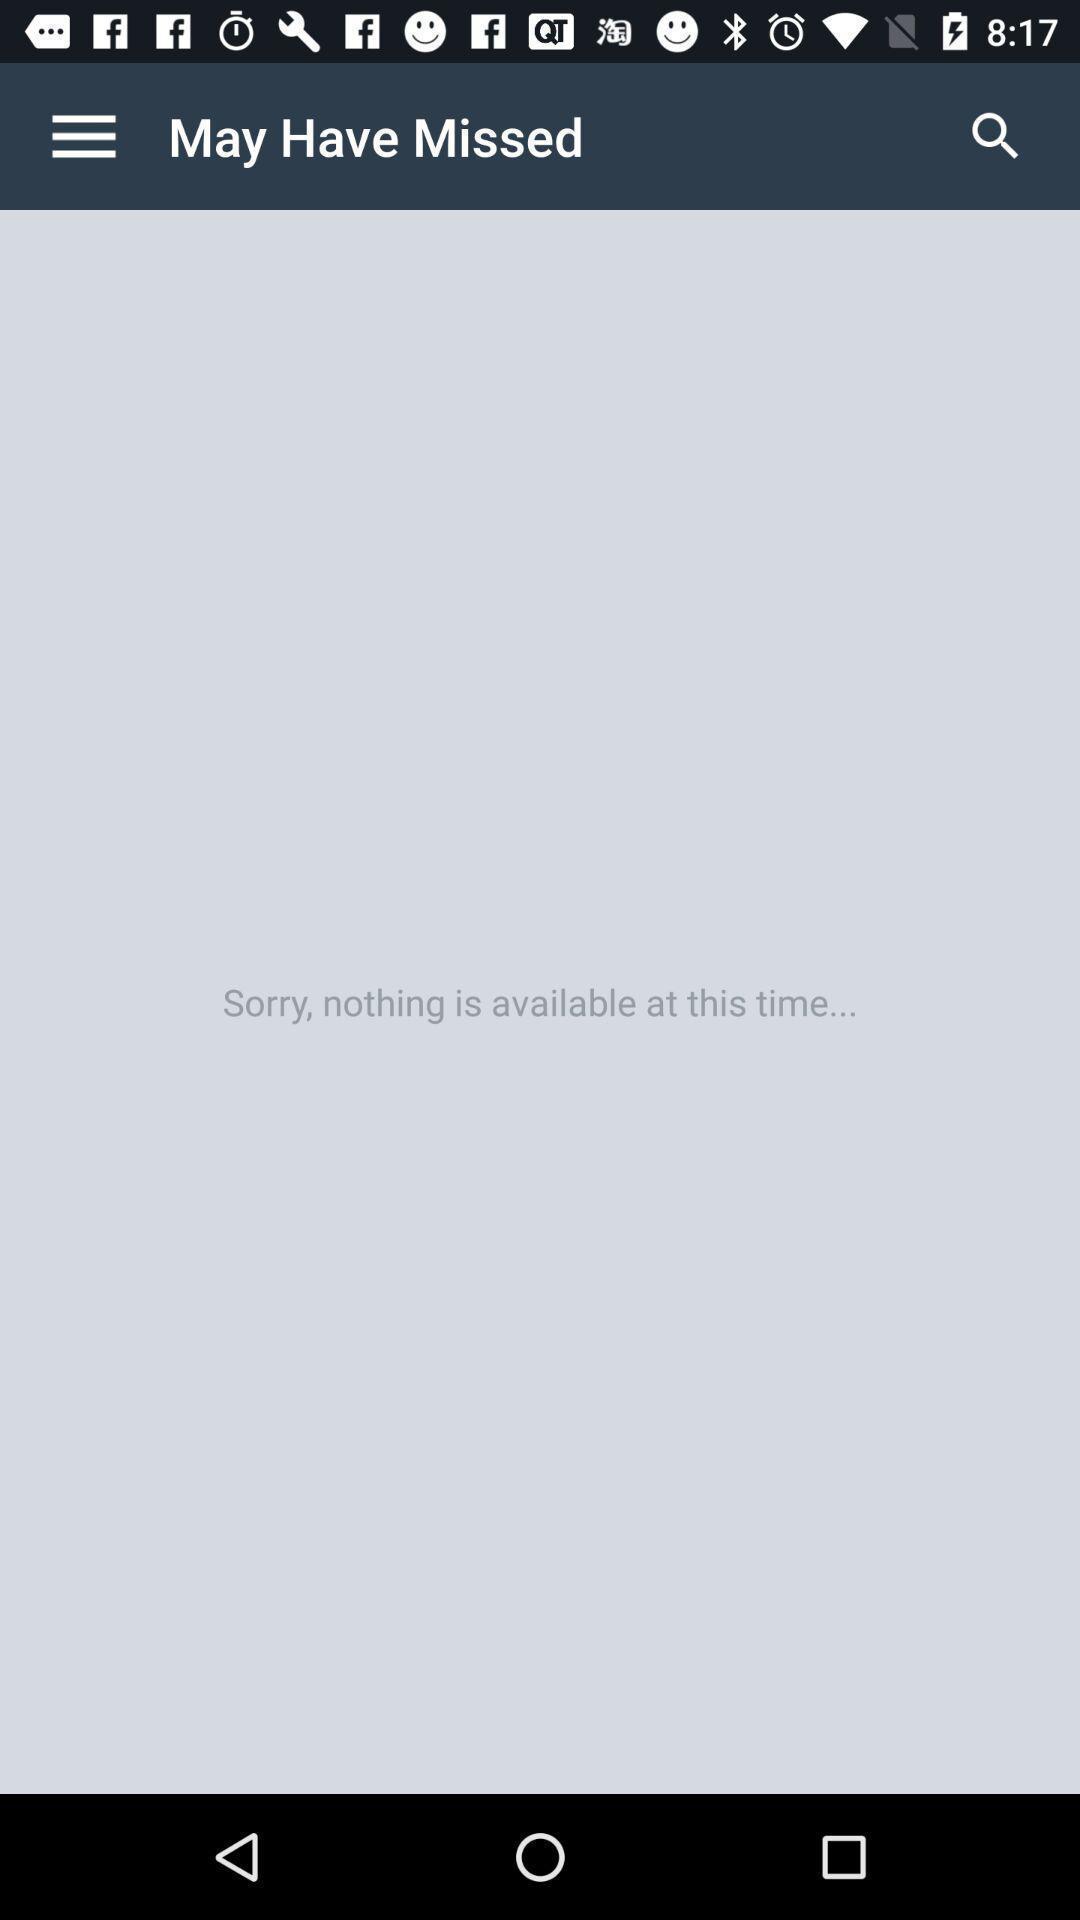Tell me what you see in this picture. Search page displaying nothing found. 